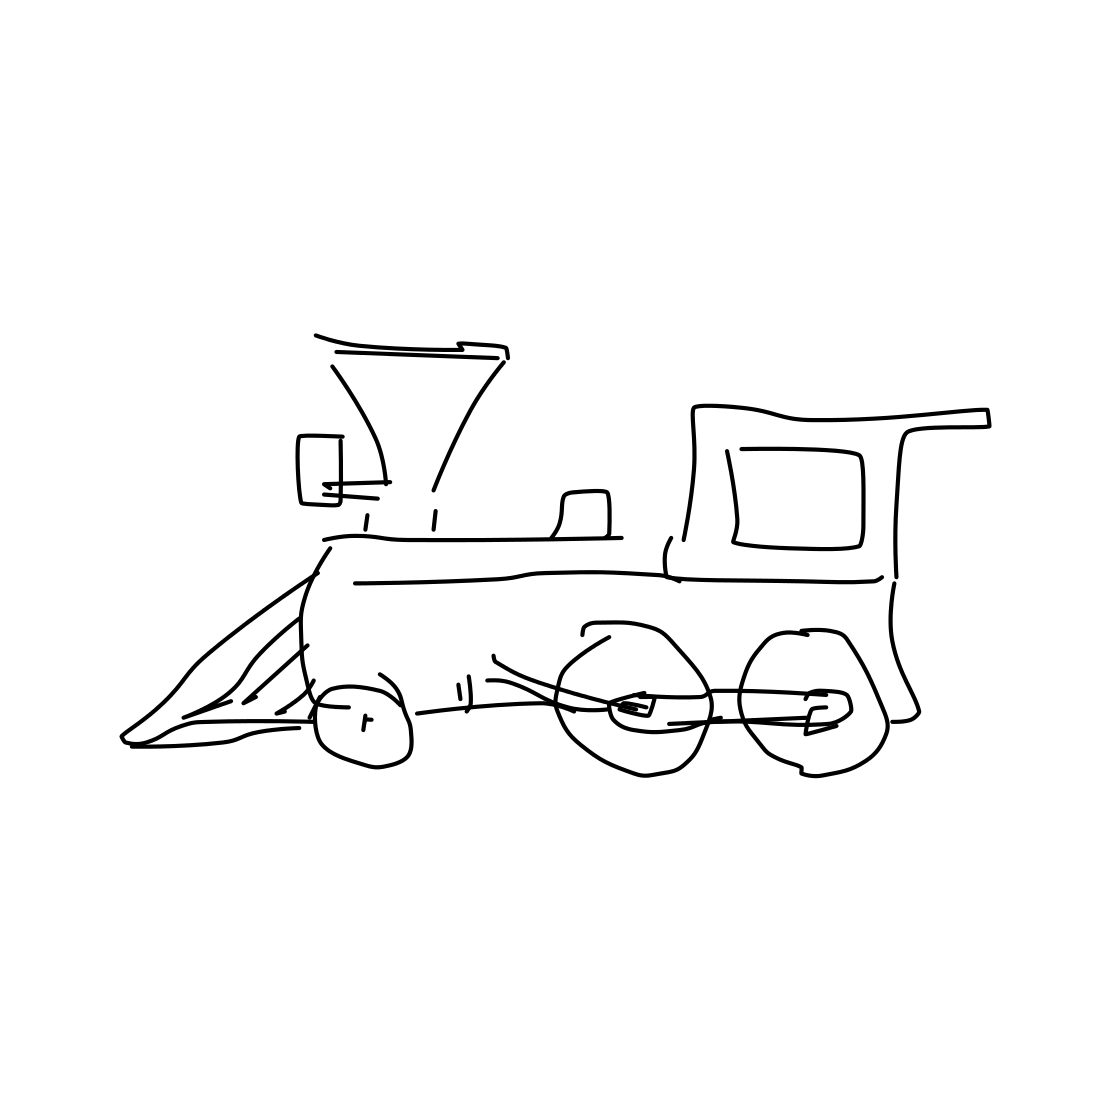Is this a train in the image? Yes, it is a drawing of a train, characterized by the iconic steam engine design, complete with a smokestack, a prominent cowcatcher at the front, large wheels, and the engineer's cabin. 